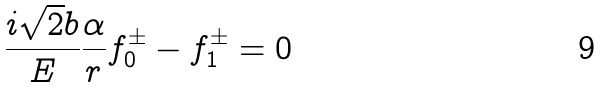<formula> <loc_0><loc_0><loc_500><loc_500>\frac { i \sqrt { 2 } b } { E } \frac { \alpha } { r } f _ { 0 } ^ { \pm } - f _ { 1 } ^ { \pm } = 0</formula> 